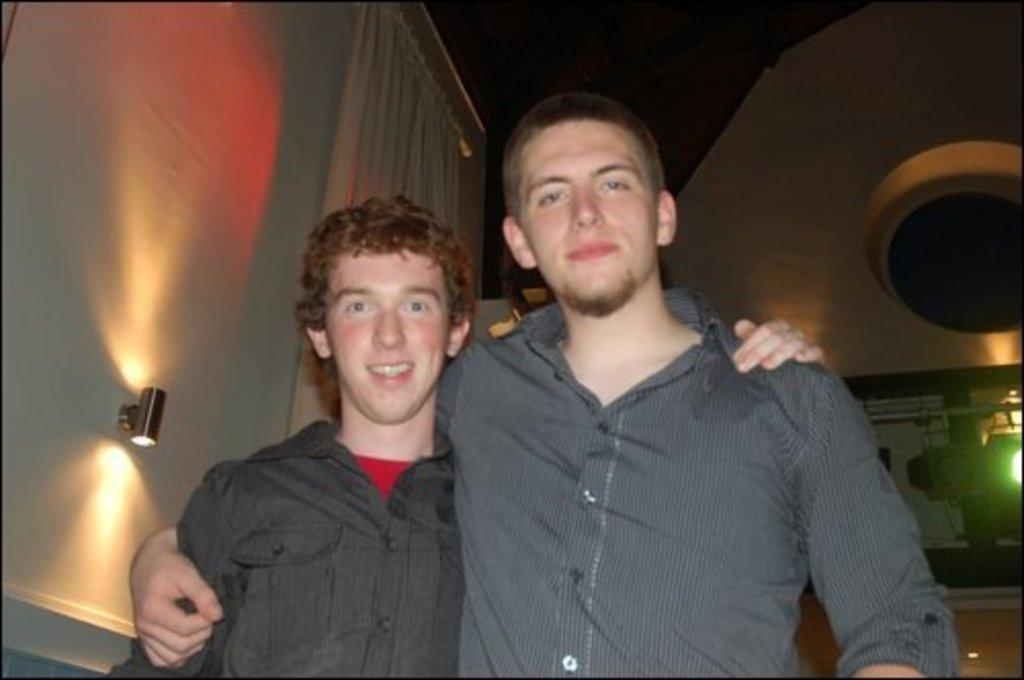How many people are in the image? There are two men in the image. What is the facial expression of the men in the image? The men are smiling. What can be seen in the background of the image? There are lights, walls, a curtain, and some objects in the background of the image. How would you describe the lighting in the image? The background of the image is dark. What type of flowers are being compared in the song that is playing in the image? There is no song or flowers present in the image; it features two men smiling with a dark background. 